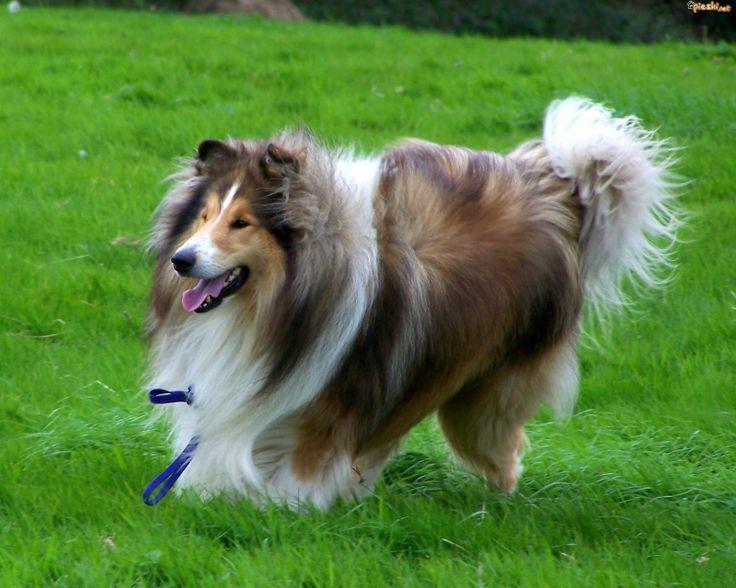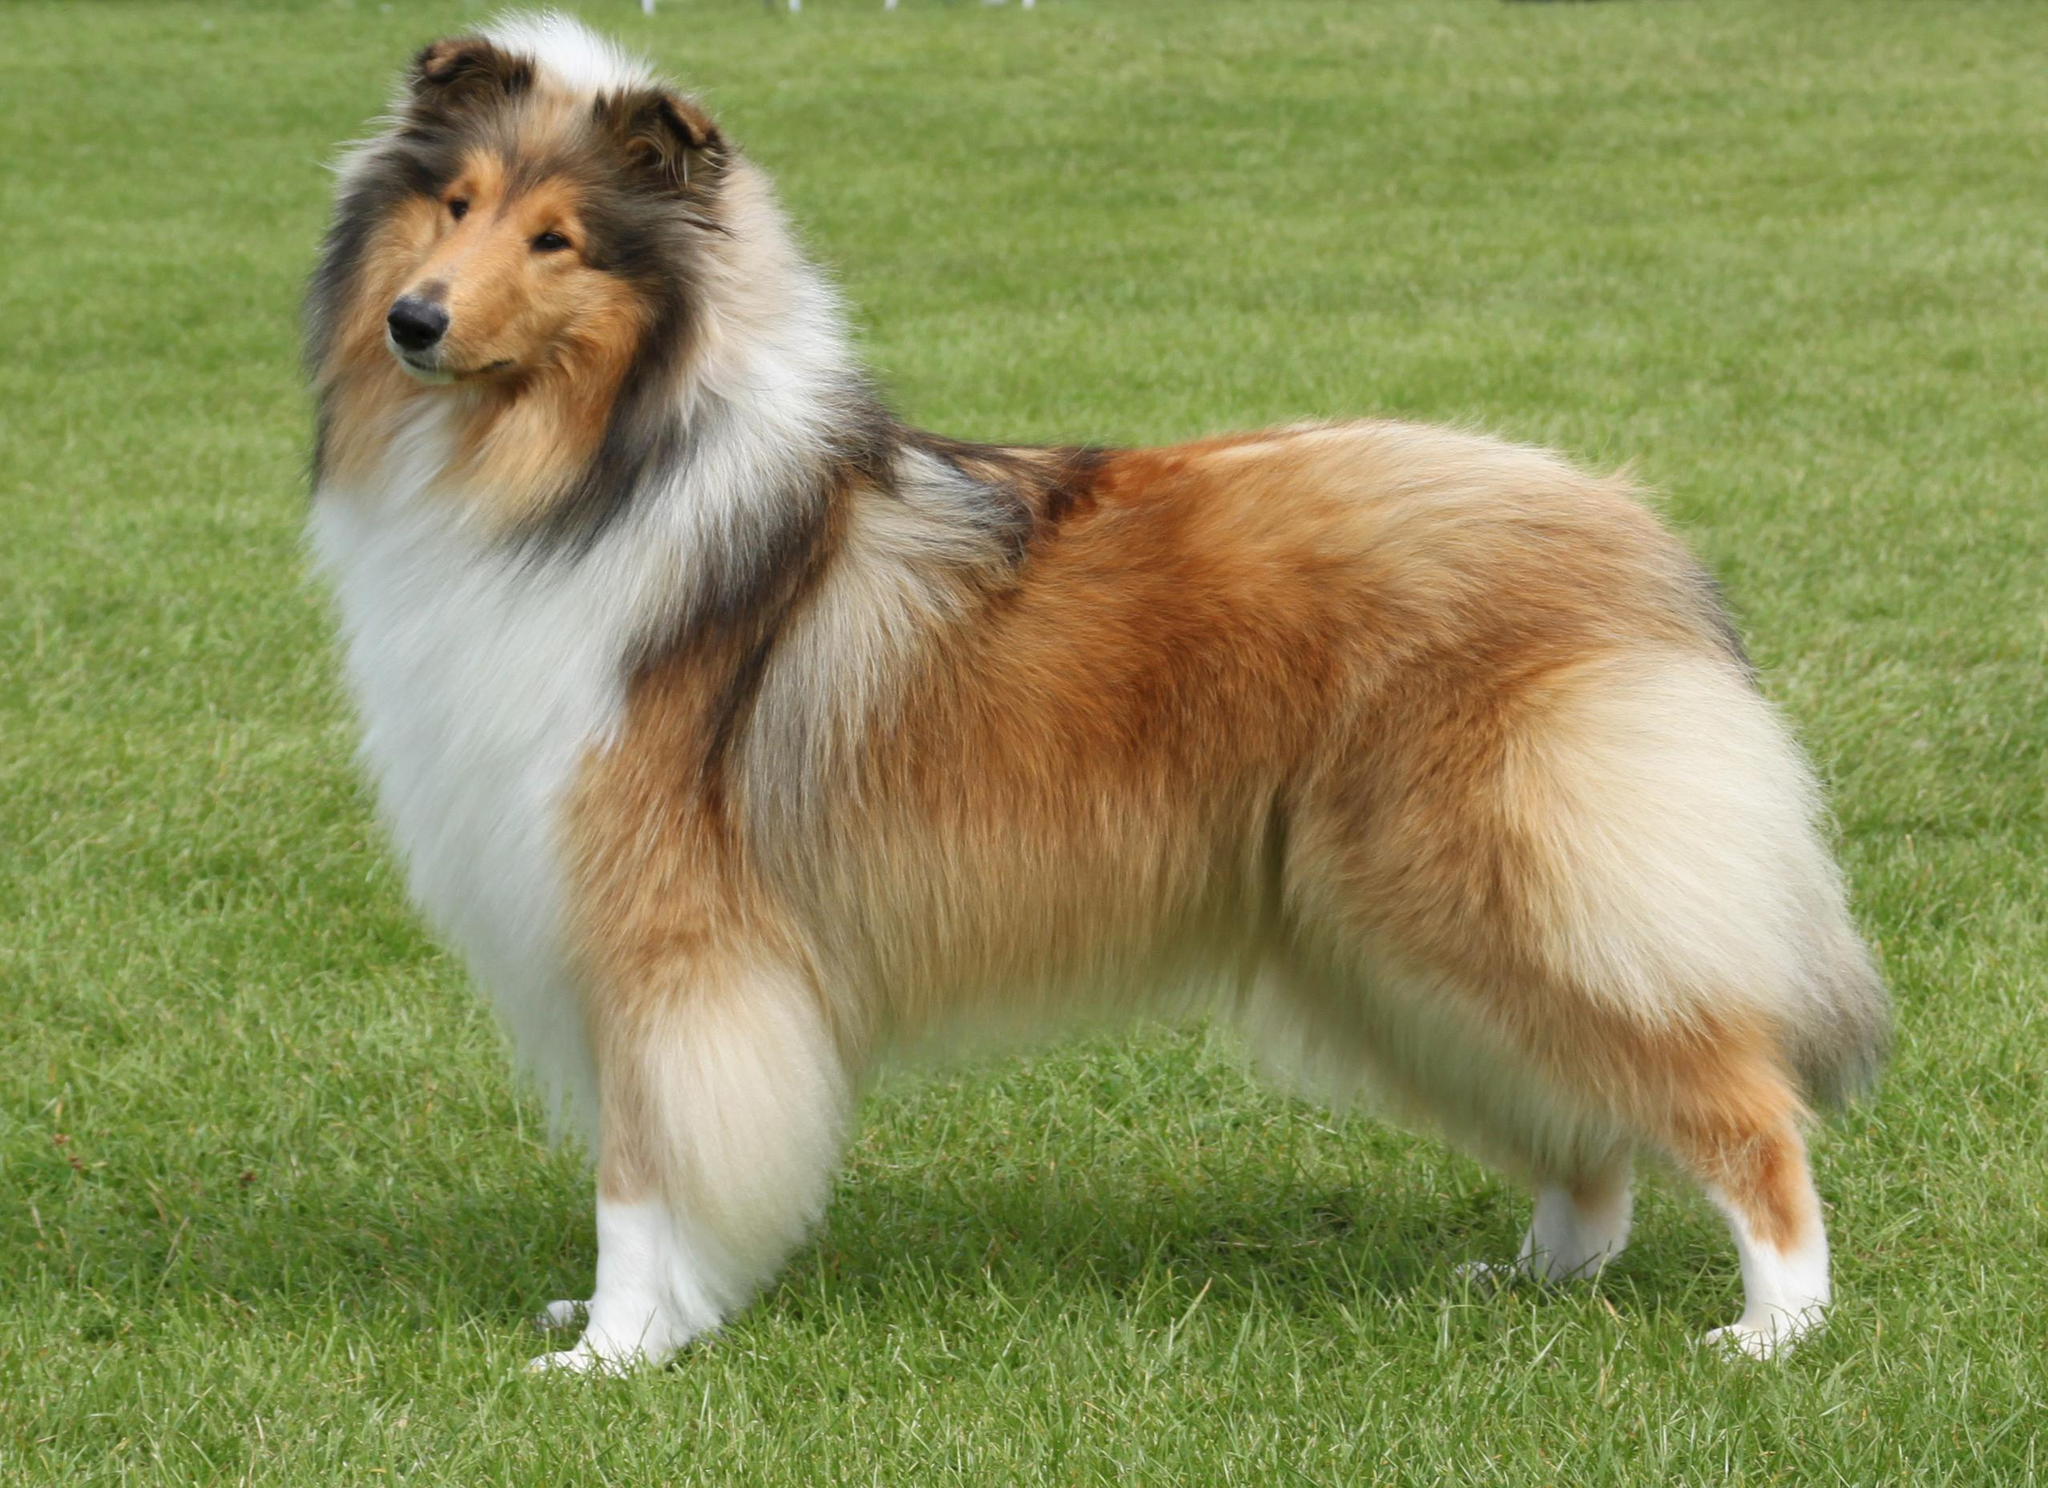The first image is the image on the left, the second image is the image on the right. Considering the images on both sides, is "both collies are standing and facing left" valid? Answer yes or no. Yes. 